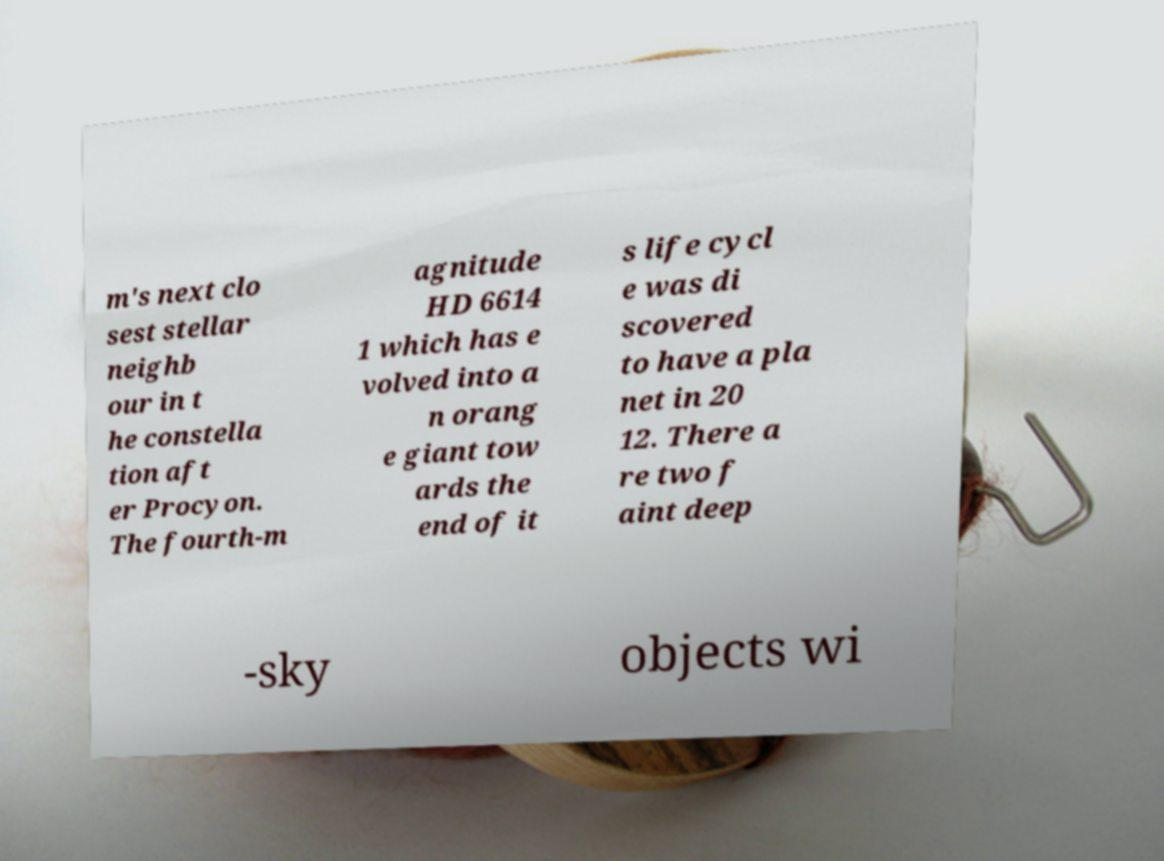Please identify and transcribe the text found in this image. m's next clo sest stellar neighb our in t he constella tion aft er Procyon. The fourth-m agnitude HD 6614 1 which has e volved into a n orang e giant tow ards the end of it s life cycl e was di scovered to have a pla net in 20 12. There a re two f aint deep -sky objects wi 